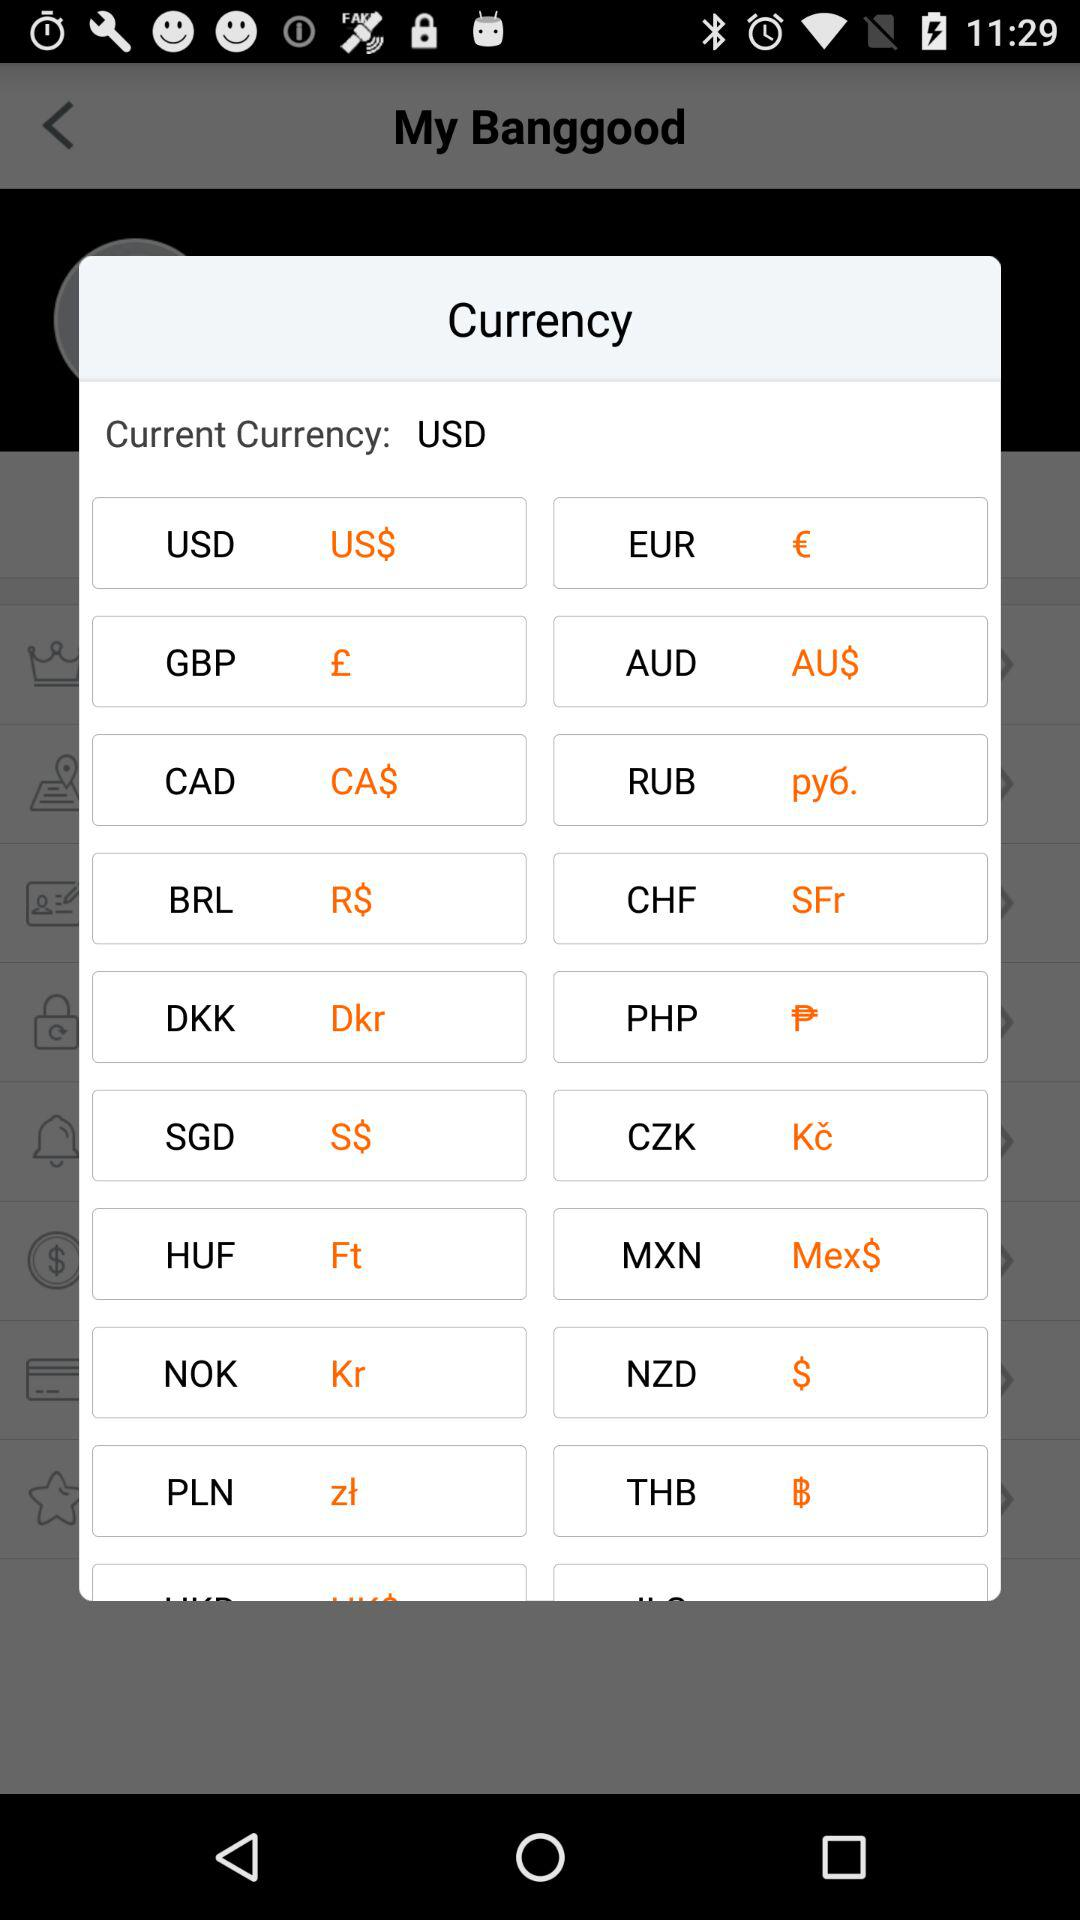What is the current currency? The current currency is United States dollars. 